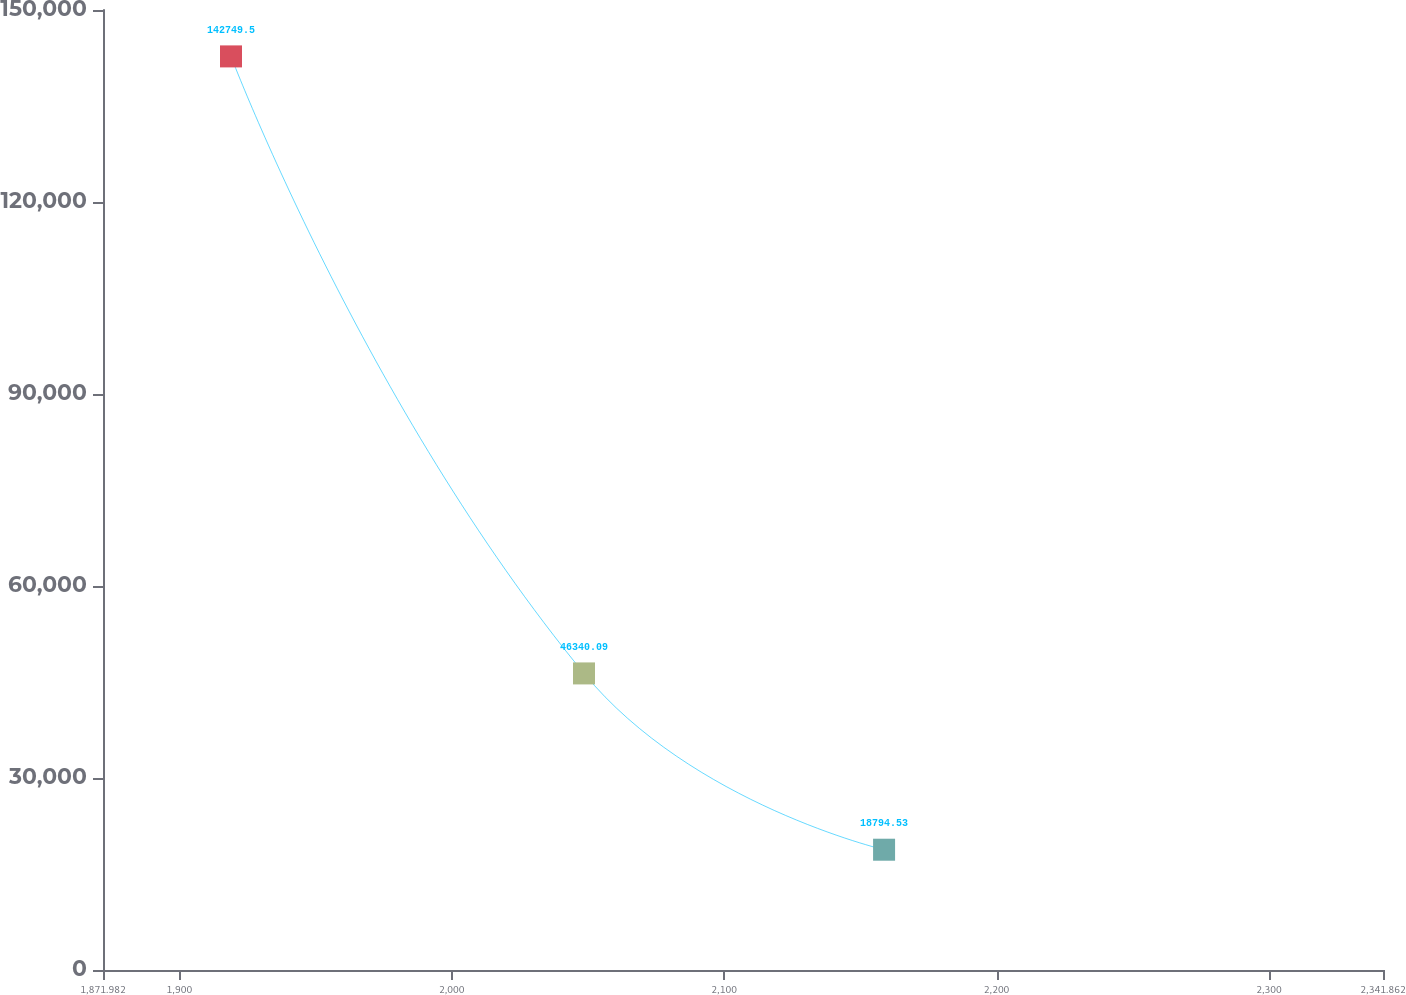Convert chart. <chart><loc_0><loc_0><loc_500><loc_500><line_chart><ecel><fcel>Unnamed: 1<nl><fcel>1918.97<fcel>142750<nl><fcel>2048.56<fcel>46340.1<nl><fcel>2158.71<fcel>18794.5<nl><fcel>2343.34<fcel>32567.3<nl><fcel>2388.85<fcel>5021.75<nl></chart> 